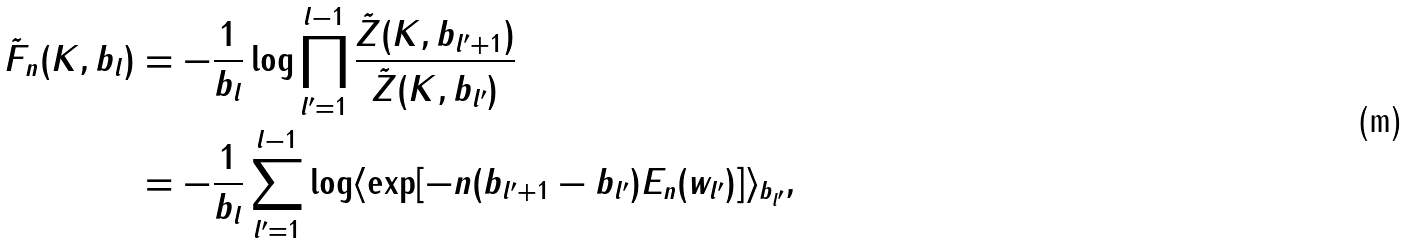<formula> <loc_0><loc_0><loc_500><loc_500>\tilde { F } _ { n } ( K , b _ { l } ) & = - \frac { 1 } { b _ { l } } \log \prod _ { l ^ { \prime } = 1 } ^ { l - 1 } \frac { \tilde { Z } ( K , b _ { l ^ { \prime } + 1 } ) } { \tilde { Z } ( K , b _ { l ^ { \prime } } ) } \\ & = - \frac { 1 } { b _ { l } } \sum _ { l ^ { \prime } = 1 } ^ { l - 1 } \log \langle \exp [ - n ( b _ { l ^ { \prime } + 1 } - b _ { l ^ { \prime } } ) E _ { n } ( w _ { l ^ { \prime } } ) ] \rangle _ { b _ { l ^ { \prime } } } ,</formula> 